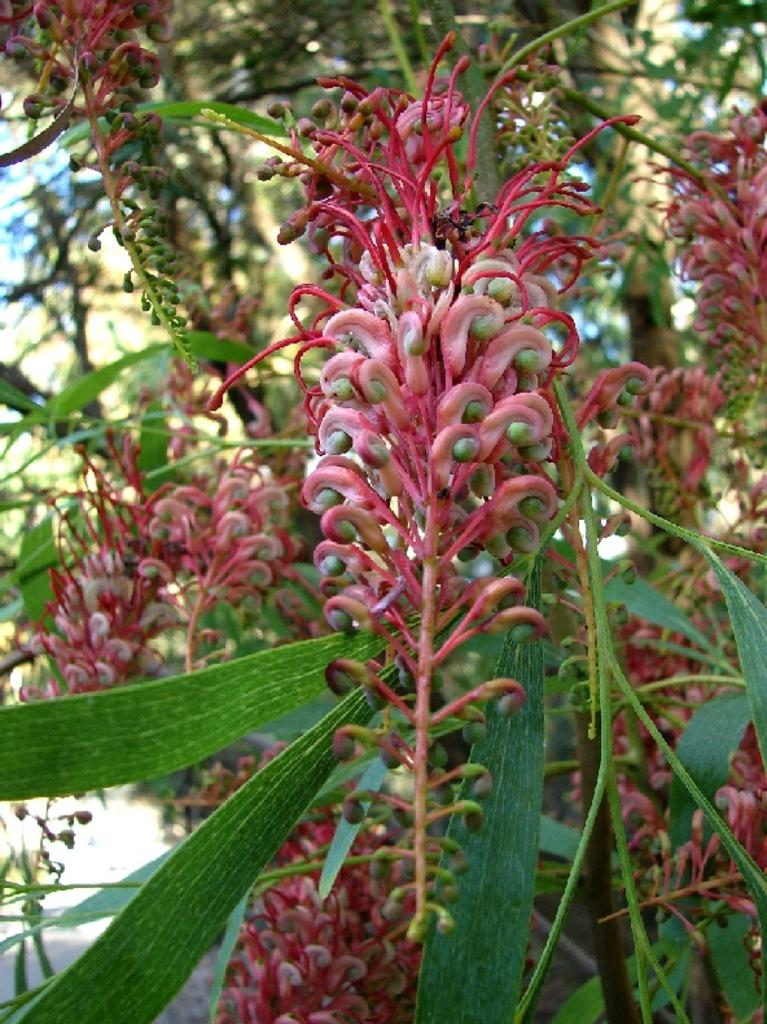What types of vegetation can be seen in the foreground of the image? There are plants and flowers in the foreground of the image. What can be seen in the background of the image? There are trees in the background of the image. What is located at the bottom of the image? There is a walkway at the bottom of the image. What type of acoustics can be heard from the plants and flowers in the image? There is no sound or acoustics associated with the plants and flowers in the image. How many dogs are visible in the image? There are no dogs present in the image. 